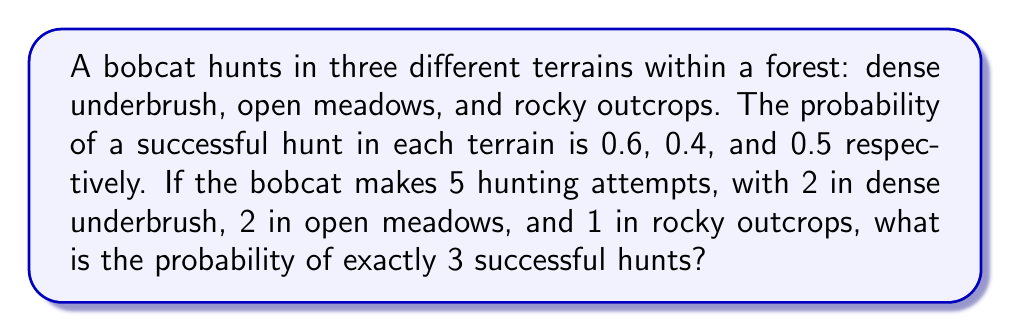Give your solution to this math problem. To solve this problem, we'll use the concept of binomial probability for each terrain and then combine them using the multiplication principle.

Step 1: Calculate the probability of success for each terrain:
- Dense underbrush (D): $P(D) = 0.6$
- Open meadows (M): $P(M) = 0.4$
- Rocky outcrops (R): $P(R) = 0.5$

Step 2: We need to consider all possible combinations of 3 successful hunts across the three terrains. The possibilities are:
1. 2 in D, 1 in M, 0 in R
2. 2 in D, 0 in M, 1 in R
3. 1 in D, 2 in M, 0 in R
4. 1 in D, 1 in M, 1 in R
5. 0 in D, 2 in M, 1 in R

Step 3: Calculate the probability for each combination using binomial probability formula:
$$P(X = k) = \binom{n}{k} p^k (1-p)^{n-k}$$

1. $P(2D, 1M, 0R) = \binom{2}{2}(0.6)^2 \cdot \binom{2}{1}(0.4)^1(0.6)^1 \cdot \binom{1}{0}(0.5)^0(0.5)^1$
2. $P(2D, 0M, 1R) = \binom{2}{2}(0.6)^2 \cdot \binom{2}{0}(0.4)^0(0.6)^2 \cdot \binom{1}{1}(0.5)^1(0.5)^0$
3. $P(1D, 2M, 0R) = \binom{2}{1}(0.6)^1(0.4)^1 \cdot \binom{2}{2}(0.4)^2 \cdot \binom{1}{0}(0.5)^0(0.5)^1$
4. $P(1D, 1M, 1R) = \binom{2}{1}(0.6)^1(0.4)^1 \cdot \binom{2}{1}(0.4)^1(0.6)^1 \cdot \binom{1}{1}(0.5)^1(0.5)^0$
5. $P(0D, 2M, 1R) = \binom{2}{0}(0.6)^0(0.4)^2 \cdot \binom{2}{2}(0.4)^2 \cdot \binom{1}{1}(0.5)^1(0.5)^0$

Step 4: Calculate each probability:
1. $P(2D, 1M, 0R) = 1 \cdot 0.36 \cdot 2 \cdot 0.24 \cdot 1 \cdot 0.5 = 0.0864$
2. $P(2D, 0M, 1R) = 1 \cdot 0.36 \cdot 1 \cdot 0.36 \cdot 1 \cdot 0.5 = 0.0648$
3. $P(1D, 2M, 0R) = 2 \cdot 0.24 \cdot 1 \cdot 0.16 \cdot 1 \cdot 0.5 = 0.0384$
4. $P(1D, 1M, 1R) = 2 \cdot 0.24 \cdot 2 \cdot 0.24 \cdot 1 \cdot 0.5 = 0.1152$
5. $P(0D, 2M, 1R) = 1 \cdot 0.16 \cdot 1 \cdot 0.16 \cdot 1 \cdot 0.5 = 0.0128$

Step 5: Sum all probabilities to get the total probability of exactly 3 successful hunts:

$P(\text{3 successful hunts}) = 0.0864 + 0.0648 + 0.0384 + 0.1152 + 0.0128 = 0.3176$
Answer: 0.3176 